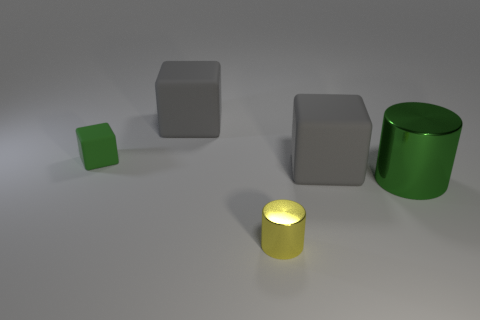Subtract all gray cubes. How many cubes are left? 1 Add 2 big red cylinders. How many objects exist? 7 Subtract all blocks. How many objects are left? 2 Add 5 rubber blocks. How many rubber blocks exist? 8 Subtract 0 cyan spheres. How many objects are left? 5 Subtract all big green shiny cylinders. Subtract all gray things. How many objects are left? 2 Add 1 green shiny objects. How many green shiny objects are left? 2 